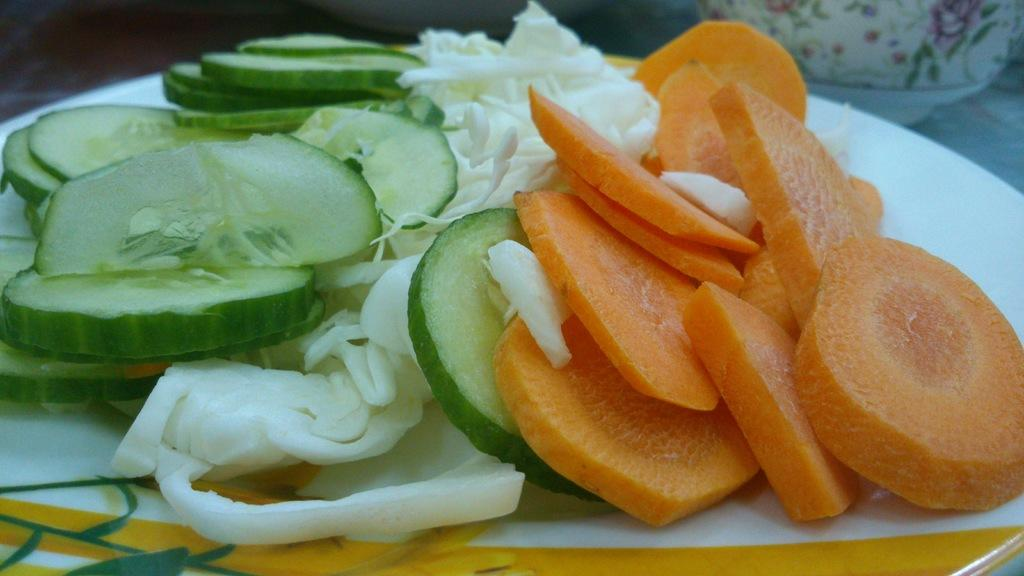What is on the white plate in the image? The plate contains chopped carrots, chopped cabbage, and chopped cucumbers. Can you describe the contents of the plate in more detail? The plate contains chopped carrots, chopped cabbage, and chopped cucumbers. Where is the cup located in the image? The cup is in the right bottom of the image. What is the condition of the street in the image? There is no street present in the image; it only contains a white plate with chopped vegetables and a cup. 